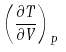Convert formula to latex. <formula><loc_0><loc_0><loc_500><loc_500>\left ( { \frac { \partial T } { \partial V } } \right ) _ { P }</formula> 